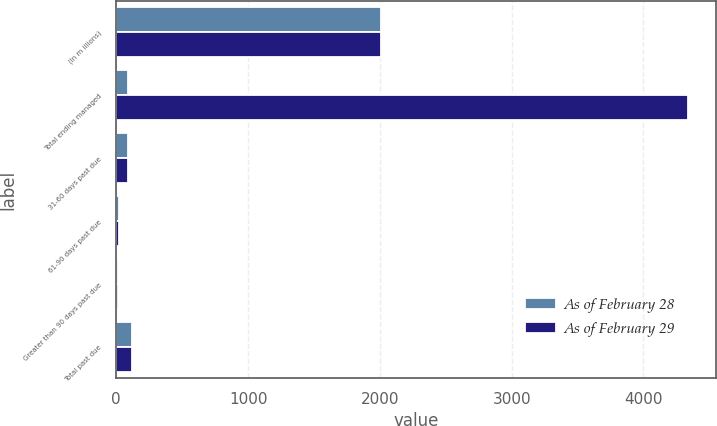Convert chart. <chart><loc_0><loc_0><loc_500><loc_500><stacked_bar_chart><ecel><fcel>(In m illions)<fcel>Total ending managed<fcel>31-60 days past due<fcel>61-90 days past due<fcel>Greater than 90 days past due<fcel>Total past due<nl><fcel>As of February 28<fcel>2012<fcel>86.6<fcel>85.1<fcel>21.8<fcel>9.6<fcel>116.5<nl><fcel>As of February 29<fcel>2011<fcel>4334.6<fcel>86.6<fcel>24.2<fcel>10.5<fcel>121.3<nl></chart> 